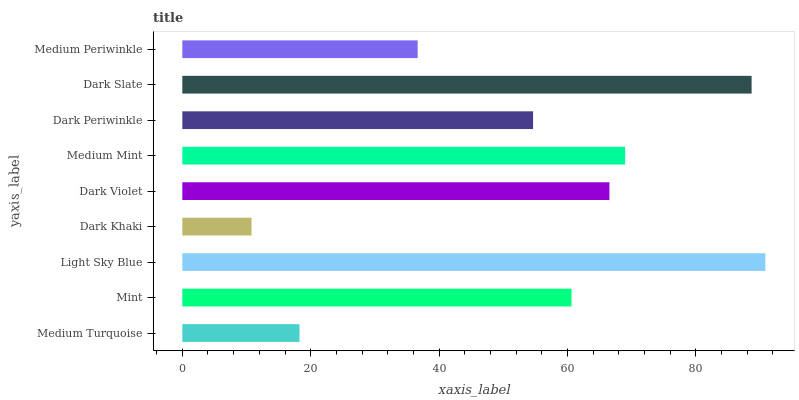Is Dark Khaki the minimum?
Answer yes or no. Yes. Is Light Sky Blue the maximum?
Answer yes or no. Yes. Is Mint the minimum?
Answer yes or no. No. Is Mint the maximum?
Answer yes or no. No. Is Mint greater than Medium Turquoise?
Answer yes or no. Yes. Is Medium Turquoise less than Mint?
Answer yes or no. Yes. Is Medium Turquoise greater than Mint?
Answer yes or no. No. Is Mint less than Medium Turquoise?
Answer yes or no. No. Is Mint the high median?
Answer yes or no. Yes. Is Mint the low median?
Answer yes or no. Yes. Is Light Sky Blue the high median?
Answer yes or no. No. Is Dark Slate the low median?
Answer yes or no. No. 